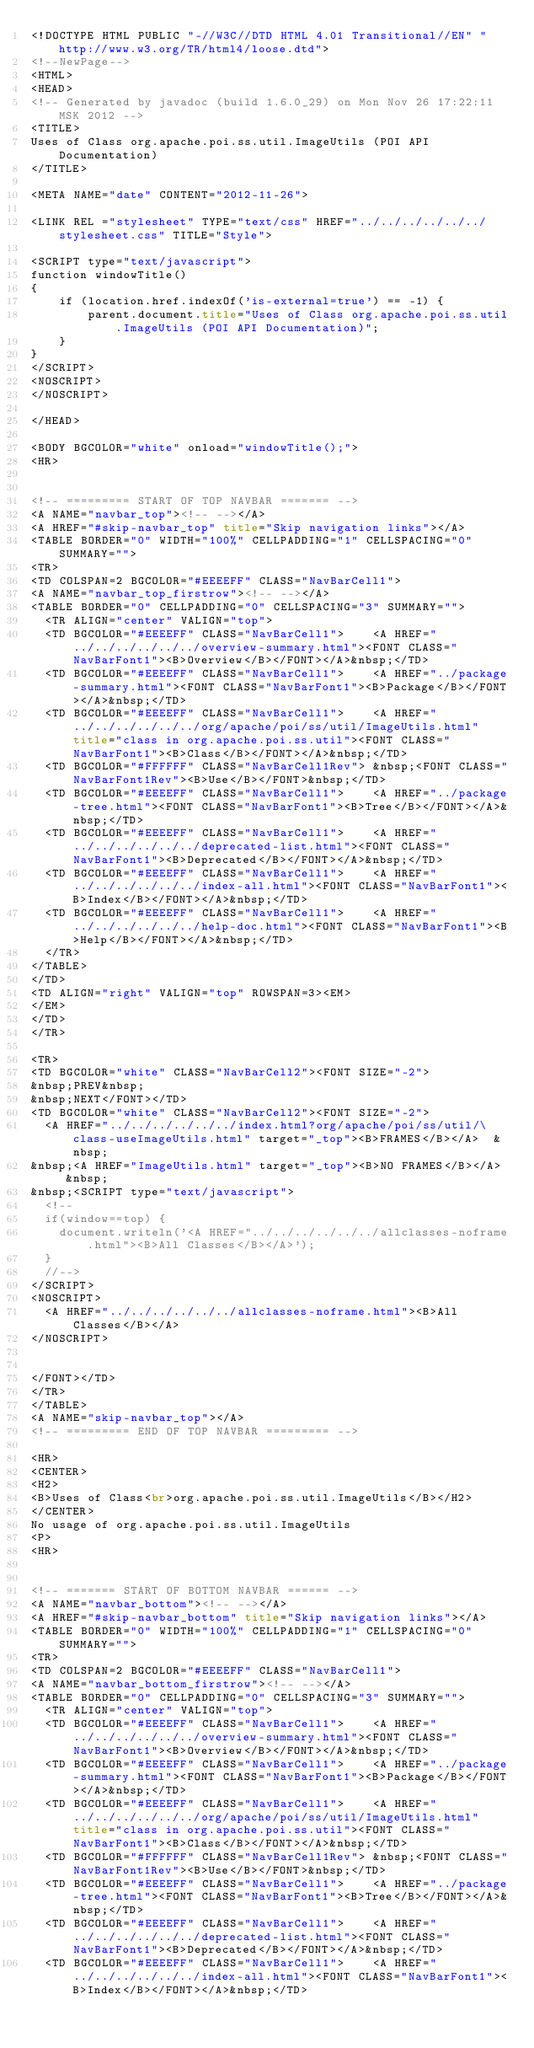Convert code to text. <code><loc_0><loc_0><loc_500><loc_500><_HTML_><!DOCTYPE HTML PUBLIC "-//W3C//DTD HTML 4.01 Transitional//EN" "http://www.w3.org/TR/html4/loose.dtd">
<!--NewPage-->
<HTML>
<HEAD>
<!-- Generated by javadoc (build 1.6.0_29) on Mon Nov 26 17:22:11 MSK 2012 -->
<TITLE>
Uses of Class org.apache.poi.ss.util.ImageUtils (POI API Documentation)
</TITLE>

<META NAME="date" CONTENT="2012-11-26">

<LINK REL ="stylesheet" TYPE="text/css" HREF="../../../../../../stylesheet.css" TITLE="Style">

<SCRIPT type="text/javascript">
function windowTitle()
{
    if (location.href.indexOf('is-external=true') == -1) {
        parent.document.title="Uses of Class org.apache.poi.ss.util.ImageUtils (POI API Documentation)";
    }
}
</SCRIPT>
<NOSCRIPT>
</NOSCRIPT>

</HEAD>

<BODY BGCOLOR="white" onload="windowTitle();">
<HR>


<!-- ========= START OF TOP NAVBAR ======= -->
<A NAME="navbar_top"><!-- --></A>
<A HREF="#skip-navbar_top" title="Skip navigation links"></A>
<TABLE BORDER="0" WIDTH="100%" CELLPADDING="1" CELLSPACING="0" SUMMARY="">
<TR>
<TD COLSPAN=2 BGCOLOR="#EEEEFF" CLASS="NavBarCell1">
<A NAME="navbar_top_firstrow"><!-- --></A>
<TABLE BORDER="0" CELLPADDING="0" CELLSPACING="3" SUMMARY="">
  <TR ALIGN="center" VALIGN="top">
  <TD BGCOLOR="#EEEEFF" CLASS="NavBarCell1">    <A HREF="../../../../../../overview-summary.html"><FONT CLASS="NavBarFont1"><B>Overview</B></FONT></A>&nbsp;</TD>
  <TD BGCOLOR="#EEEEFF" CLASS="NavBarCell1">    <A HREF="../package-summary.html"><FONT CLASS="NavBarFont1"><B>Package</B></FONT></A>&nbsp;</TD>
  <TD BGCOLOR="#EEEEFF" CLASS="NavBarCell1">    <A HREF="../../../../../../org/apache/poi/ss/util/ImageUtils.html" title="class in org.apache.poi.ss.util"><FONT CLASS="NavBarFont1"><B>Class</B></FONT></A>&nbsp;</TD>
  <TD BGCOLOR="#FFFFFF" CLASS="NavBarCell1Rev"> &nbsp;<FONT CLASS="NavBarFont1Rev"><B>Use</B></FONT>&nbsp;</TD>
  <TD BGCOLOR="#EEEEFF" CLASS="NavBarCell1">    <A HREF="../package-tree.html"><FONT CLASS="NavBarFont1"><B>Tree</B></FONT></A>&nbsp;</TD>
  <TD BGCOLOR="#EEEEFF" CLASS="NavBarCell1">    <A HREF="../../../../../../deprecated-list.html"><FONT CLASS="NavBarFont1"><B>Deprecated</B></FONT></A>&nbsp;</TD>
  <TD BGCOLOR="#EEEEFF" CLASS="NavBarCell1">    <A HREF="../../../../../../index-all.html"><FONT CLASS="NavBarFont1"><B>Index</B></FONT></A>&nbsp;</TD>
  <TD BGCOLOR="#EEEEFF" CLASS="NavBarCell1">    <A HREF="../../../../../../help-doc.html"><FONT CLASS="NavBarFont1"><B>Help</B></FONT></A>&nbsp;</TD>
  </TR>
</TABLE>
</TD>
<TD ALIGN="right" VALIGN="top" ROWSPAN=3><EM>
</EM>
</TD>
</TR>

<TR>
<TD BGCOLOR="white" CLASS="NavBarCell2"><FONT SIZE="-2">
&nbsp;PREV&nbsp;
&nbsp;NEXT</FONT></TD>
<TD BGCOLOR="white" CLASS="NavBarCell2"><FONT SIZE="-2">
  <A HREF="../../../../../../index.html?org/apache/poi/ss/util/\class-useImageUtils.html" target="_top"><B>FRAMES</B></A>  &nbsp;
&nbsp;<A HREF="ImageUtils.html" target="_top"><B>NO FRAMES</B></A>  &nbsp;
&nbsp;<SCRIPT type="text/javascript">
  <!--
  if(window==top) {
    document.writeln('<A HREF="../../../../../../allclasses-noframe.html"><B>All Classes</B></A>');
  }
  //-->
</SCRIPT>
<NOSCRIPT>
  <A HREF="../../../../../../allclasses-noframe.html"><B>All Classes</B></A>
</NOSCRIPT>


</FONT></TD>
</TR>
</TABLE>
<A NAME="skip-navbar_top"></A>
<!-- ========= END OF TOP NAVBAR ========= -->

<HR>
<CENTER>
<H2>
<B>Uses of Class<br>org.apache.poi.ss.util.ImageUtils</B></H2>
</CENTER>
No usage of org.apache.poi.ss.util.ImageUtils
<P>
<HR>


<!-- ======= START OF BOTTOM NAVBAR ====== -->
<A NAME="navbar_bottom"><!-- --></A>
<A HREF="#skip-navbar_bottom" title="Skip navigation links"></A>
<TABLE BORDER="0" WIDTH="100%" CELLPADDING="1" CELLSPACING="0" SUMMARY="">
<TR>
<TD COLSPAN=2 BGCOLOR="#EEEEFF" CLASS="NavBarCell1">
<A NAME="navbar_bottom_firstrow"><!-- --></A>
<TABLE BORDER="0" CELLPADDING="0" CELLSPACING="3" SUMMARY="">
  <TR ALIGN="center" VALIGN="top">
  <TD BGCOLOR="#EEEEFF" CLASS="NavBarCell1">    <A HREF="../../../../../../overview-summary.html"><FONT CLASS="NavBarFont1"><B>Overview</B></FONT></A>&nbsp;</TD>
  <TD BGCOLOR="#EEEEFF" CLASS="NavBarCell1">    <A HREF="../package-summary.html"><FONT CLASS="NavBarFont1"><B>Package</B></FONT></A>&nbsp;</TD>
  <TD BGCOLOR="#EEEEFF" CLASS="NavBarCell1">    <A HREF="../../../../../../org/apache/poi/ss/util/ImageUtils.html" title="class in org.apache.poi.ss.util"><FONT CLASS="NavBarFont1"><B>Class</B></FONT></A>&nbsp;</TD>
  <TD BGCOLOR="#FFFFFF" CLASS="NavBarCell1Rev"> &nbsp;<FONT CLASS="NavBarFont1Rev"><B>Use</B></FONT>&nbsp;</TD>
  <TD BGCOLOR="#EEEEFF" CLASS="NavBarCell1">    <A HREF="../package-tree.html"><FONT CLASS="NavBarFont1"><B>Tree</B></FONT></A>&nbsp;</TD>
  <TD BGCOLOR="#EEEEFF" CLASS="NavBarCell1">    <A HREF="../../../../../../deprecated-list.html"><FONT CLASS="NavBarFont1"><B>Deprecated</B></FONT></A>&nbsp;</TD>
  <TD BGCOLOR="#EEEEFF" CLASS="NavBarCell1">    <A HREF="../../../../../../index-all.html"><FONT CLASS="NavBarFont1"><B>Index</B></FONT></A>&nbsp;</TD></code> 